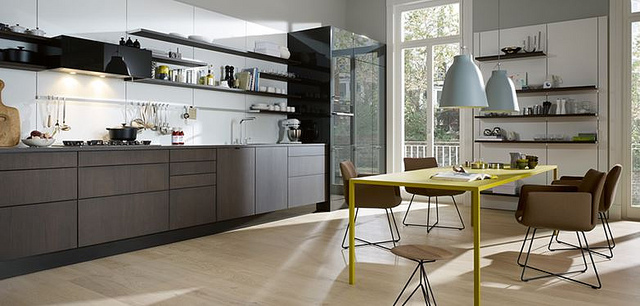<image>Who was cooking in this kitchen last evening? I don't know who was cooking last night. It could have been anyone. Who was cooking in this kitchen last evening? I am not sure who was cooking in the kitchen last evening. It could be the mom, owner, woman, or Frank. 